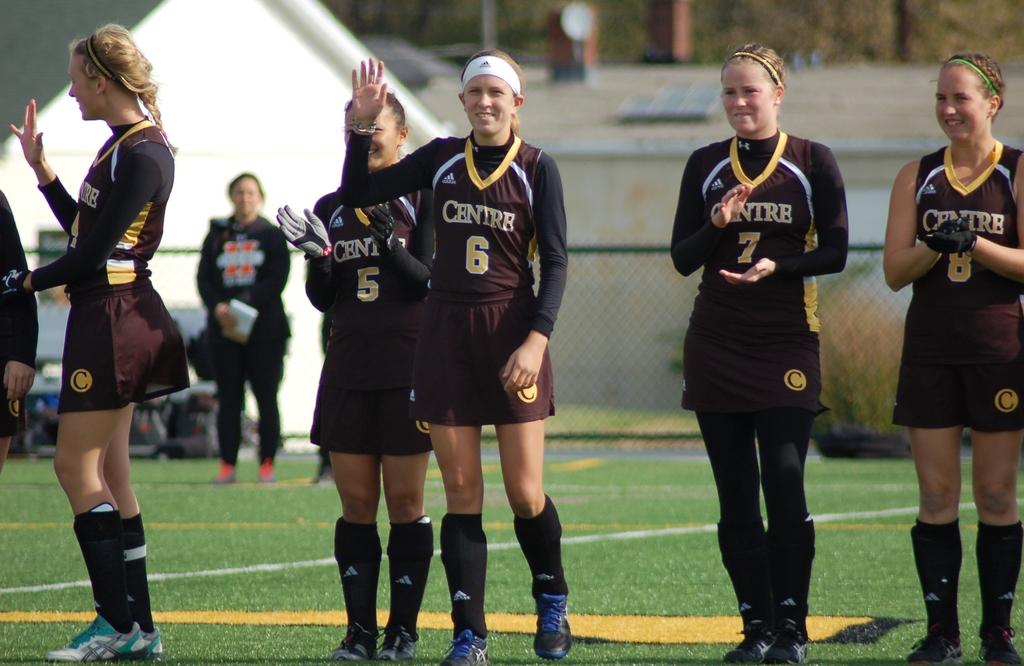What is the team school name?
Keep it short and to the point. Centre. 